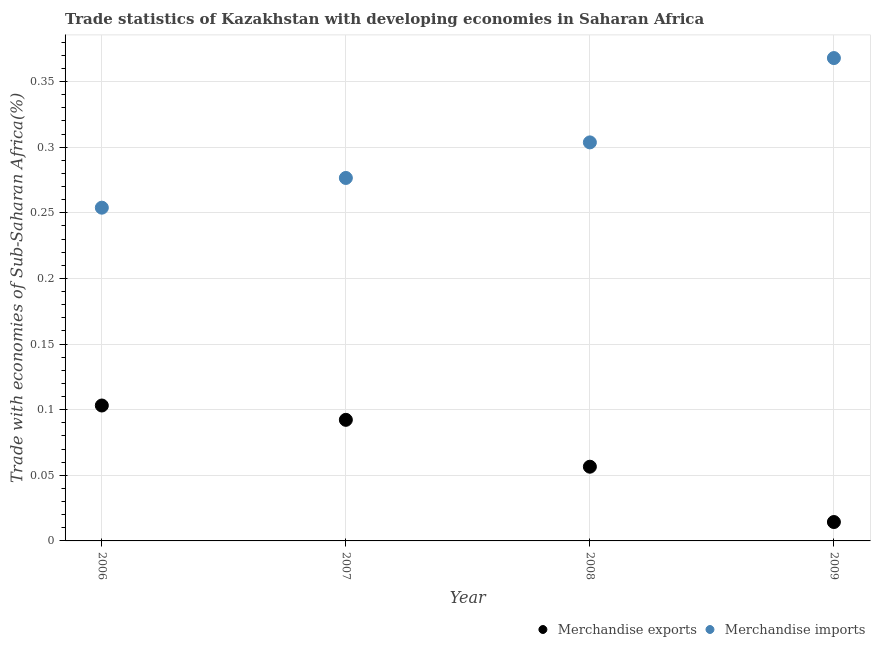What is the merchandise imports in 2009?
Provide a short and direct response. 0.37. Across all years, what is the maximum merchandise imports?
Offer a terse response. 0.37. Across all years, what is the minimum merchandise exports?
Ensure brevity in your answer.  0.01. What is the total merchandise imports in the graph?
Ensure brevity in your answer.  1.2. What is the difference between the merchandise imports in 2007 and that in 2008?
Offer a terse response. -0.03. What is the difference between the merchandise imports in 2007 and the merchandise exports in 2008?
Ensure brevity in your answer.  0.22. What is the average merchandise exports per year?
Ensure brevity in your answer.  0.07. In the year 2006, what is the difference between the merchandise imports and merchandise exports?
Provide a short and direct response. 0.15. In how many years, is the merchandise imports greater than 0.27 %?
Provide a short and direct response. 3. What is the ratio of the merchandise imports in 2006 to that in 2008?
Ensure brevity in your answer.  0.84. What is the difference between the highest and the second highest merchandise exports?
Make the answer very short. 0.01. What is the difference between the highest and the lowest merchandise imports?
Ensure brevity in your answer.  0.11. Is the sum of the merchandise exports in 2006 and 2008 greater than the maximum merchandise imports across all years?
Provide a succinct answer. No. Is the merchandise imports strictly greater than the merchandise exports over the years?
Your response must be concise. Yes. Is the merchandise imports strictly less than the merchandise exports over the years?
Keep it short and to the point. No. How many dotlines are there?
Give a very brief answer. 2. How many years are there in the graph?
Make the answer very short. 4. Does the graph contain any zero values?
Give a very brief answer. No. How many legend labels are there?
Offer a terse response. 2. How are the legend labels stacked?
Your answer should be compact. Horizontal. What is the title of the graph?
Make the answer very short. Trade statistics of Kazakhstan with developing economies in Saharan Africa. What is the label or title of the X-axis?
Your answer should be compact. Year. What is the label or title of the Y-axis?
Provide a short and direct response. Trade with economies of Sub-Saharan Africa(%). What is the Trade with economies of Sub-Saharan Africa(%) in Merchandise exports in 2006?
Offer a very short reply. 0.1. What is the Trade with economies of Sub-Saharan Africa(%) of Merchandise imports in 2006?
Give a very brief answer. 0.25. What is the Trade with economies of Sub-Saharan Africa(%) of Merchandise exports in 2007?
Provide a short and direct response. 0.09. What is the Trade with economies of Sub-Saharan Africa(%) in Merchandise imports in 2007?
Offer a terse response. 0.28. What is the Trade with economies of Sub-Saharan Africa(%) in Merchandise exports in 2008?
Provide a succinct answer. 0.06. What is the Trade with economies of Sub-Saharan Africa(%) of Merchandise imports in 2008?
Offer a very short reply. 0.3. What is the Trade with economies of Sub-Saharan Africa(%) in Merchandise exports in 2009?
Your answer should be compact. 0.01. What is the Trade with economies of Sub-Saharan Africa(%) of Merchandise imports in 2009?
Your answer should be very brief. 0.37. Across all years, what is the maximum Trade with economies of Sub-Saharan Africa(%) in Merchandise exports?
Keep it short and to the point. 0.1. Across all years, what is the maximum Trade with economies of Sub-Saharan Africa(%) in Merchandise imports?
Offer a terse response. 0.37. Across all years, what is the minimum Trade with economies of Sub-Saharan Africa(%) in Merchandise exports?
Keep it short and to the point. 0.01. Across all years, what is the minimum Trade with economies of Sub-Saharan Africa(%) of Merchandise imports?
Give a very brief answer. 0.25. What is the total Trade with economies of Sub-Saharan Africa(%) in Merchandise exports in the graph?
Ensure brevity in your answer.  0.27. What is the total Trade with economies of Sub-Saharan Africa(%) in Merchandise imports in the graph?
Offer a very short reply. 1.2. What is the difference between the Trade with economies of Sub-Saharan Africa(%) in Merchandise exports in 2006 and that in 2007?
Offer a very short reply. 0.01. What is the difference between the Trade with economies of Sub-Saharan Africa(%) of Merchandise imports in 2006 and that in 2007?
Keep it short and to the point. -0.02. What is the difference between the Trade with economies of Sub-Saharan Africa(%) of Merchandise exports in 2006 and that in 2008?
Give a very brief answer. 0.05. What is the difference between the Trade with economies of Sub-Saharan Africa(%) of Merchandise imports in 2006 and that in 2008?
Your answer should be compact. -0.05. What is the difference between the Trade with economies of Sub-Saharan Africa(%) of Merchandise exports in 2006 and that in 2009?
Provide a succinct answer. 0.09. What is the difference between the Trade with economies of Sub-Saharan Africa(%) in Merchandise imports in 2006 and that in 2009?
Provide a succinct answer. -0.11. What is the difference between the Trade with economies of Sub-Saharan Africa(%) of Merchandise exports in 2007 and that in 2008?
Provide a succinct answer. 0.04. What is the difference between the Trade with economies of Sub-Saharan Africa(%) of Merchandise imports in 2007 and that in 2008?
Provide a short and direct response. -0.03. What is the difference between the Trade with economies of Sub-Saharan Africa(%) in Merchandise exports in 2007 and that in 2009?
Offer a terse response. 0.08. What is the difference between the Trade with economies of Sub-Saharan Africa(%) of Merchandise imports in 2007 and that in 2009?
Keep it short and to the point. -0.09. What is the difference between the Trade with economies of Sub-Saharan Africa(%) of Merchandise exports in 2008 and that in 2009?
Your response must be concise. 0.04. What is the difference between the Trade with economies of Sub-Saharan Africa(%) in Merchandise imports in 2008 and that in 2009?
Ensure brevity in your answer.  -0.06. What is the difference between the Trade with economies of Sub-Saharan Africa(%) of Merchandise exports in 2006 and the Trade with economies of Sub-Saharan Africa(%) of Merchandise imports in 2007?
Keep it short and to the point. -0.17. What is the difference between the Trade with economies of Sub-Saharan Africa(%) in Merchandise exports in 2006 and the Trade with economies of Sub-Saharan Africa(%) in Merchandise imports in 2008?
Keep it short and to the point. -0.2. What is the difference between the Trade with economies of Sub-Saharan Africa(%) in Merchandise exports in 2006 and the Trade with economies of Sub-Saharan Africa(%) in Merchandise imports in 2009?
Provide a succinct answer. -0.26. What is the difference between the Trade with economies of Sub-Saharan Africa(%) of Merchandise exports in 2007 and the Trade with economies of Sub-Saharan Africa(%) of Merchandise imports in 2008?
Provide a succinct answer. -0.21. What is the difference between the Trade with economies of Sub-Saharan Africa(%) in Merchandise exports in 2007 and the Trade with economies of Sub-Saharan Africa(%) in Merchandise imports in 2009?
Make the answer very short. -0.28. What is the difference between the Trade with economies of Sub-Saharan Africa(%) in Merchandise exports in 2008 and the Trade with economies of Sub-Saharan Africa(%) in Merchandise imports in 2009?
Offer a very short reply. -0.31. What is the average Trade with economies of Sub-Saharan Africa(%) of Merchandise exports per year?
Ensure brevity in your answer.  0.07. What is the average Trade with economies of Sub-Saharan Africa(%) of Merchandise imports per year?
Offer a very short reply. 0.3. In the year 2006, what is the difference between the Trade with economies of Sub-Saharan Africa(%) in Merchandise exports and Trade with economies of Sub-Saharan Africa(%) in Merchandise imports?
Ensure brevity in your answer.  -0.15. In the year 2007, what is the difference between the Trade with economies of Sub-Saharan Africa(%) in Merchandise exports and Trade with economies of Sub-Saharan Africa(%) in Merchandise imports?
Give a very brief answer. -0.18. In the year 2008, what is the difference between the Trade with economies of Sub-Saharan Africa(%) in Merchandise exports and Trade with economies of Sub-Saharan Africa(%) in Merchandise imports?
Ensure brevity in your answer.  -0.25. In the year 2009, what is the difference between the Trade with economies of Sub-Saharan Africa(%) of Merchandise exports and Trade with economies of Sub-Saharan Africa(%) of Merchandise imports?
Your response must be concise. -0.35. What is the ratio of the Trade with economies of Sub-Saharan Africa(%) of Merchandise exports in 2006 to that in 2007?
Provide a short and direct response. 1.12. What is the ratio of the Trade with economies of Sub-Saharan Africa(%) in Merchandise imports in 2006 to that in 2007?
Keep it short and to the point. 0.92. What is the ratio of the Trade with economies of Sub-Saharan Africa(%) of Merchandise exports in 2006 to that in 2008?
Provide a succinct answer. 1.82. What is the ratio of the Trade with economies of Sub-Saharan Africa(%) in Merchandise imports in 2006 to that in 2008?
Provide a succinct answer. 0.84. What is the ratio of the Trade with economies of Sub-Saharan Africa(%) of Merchandise exports in 2006 to that in 2009?
Offer a very short reply. 7.17. What is the ratio of the Trade with economies of Sub-Saharan Africa(%) in Merchandise imports in 2006 to that in 2009?
Your answer should be very brief. 0.69. What is the ratio of the Trade with economies of Sub-Saharan Africa(%) of Merchandise exports in 2007 to that in 2008?
Ensure brevity in your answer.  1.63. What is the ratio of the Trade with economies of Sub-Saharan Africa(%) of Merchandise imports in 2007 to that in 2008?
Your answer should be compact. 0.91. What is the ratio of the Trade with economies of Sub-Saharan Africa(%) in Merchandise exports in 2007 to that in 2009?
Offer a very short reply. 6.41. What is the ratio of the Trade with economies of Sub-Saharan Africa(%) of Merchandise imports in 2007 to that in 2009?
Offer a terse response. 0.75. What is the ratio of the Trade with economies of Sub-Saharan Africa(%) of Merchandise exports in 2008 to that in 2009?
Your answer should be compact. 3.93. What is the ratio of the Trade with economies of Sub-Saharan Africa(%) of Merchandise imports in 2008 to that in 2009?
Offer a terse response. 0.83. What is the difference between the highest and the second highest Trade with economies of Sub-Saharan Africa(%) of Merchandise exports?
Your answer should be compact. 0.01. What is the difference between the highest and the second highest Trade with economies of Sub-Saharan Africa(%) of Merchandise imports?
Offer a terse response. 0.06. What is the difference between the highest and the lowest Trade with economies of Sub-Saharan Africa(%) of Merchandise exports?
Ensure brevity in your answer.  0.09. What is the difference between the highest and the lowest Trade with economies of Sub-Saharan Africa(%) in Merchandise imports?
Give a very brief answer. 0.11. 